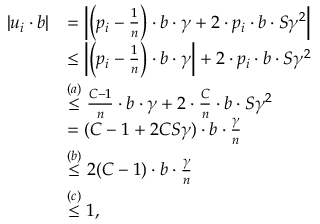Convert formula to latex. <formula><loc_0><loc_0><loc_500><loc_500>\begin{array} { r l } { | u _ { i } \cdot b | } & { = \left | \left ( p _ { i } - \frac { 1 } { n } \right ) \cdot b \cdot \gamma + 2 \cdot p _ { i } \cdot b \cdot S \gamma ^ { 2 } \right | } \\ & { \leq \left | \left ( p _ { i } - \frac { 1 } { n } \right ) \cdot b \cdot \gamma \right | + 2 \cdot p _ { i } \cdot b \cdot S \gamma ^ { 2 } } \\ & { \stackrel { ( a ) } { \leq } \frac { C - 1 } { n } \cdot b \cdot \gamma + 2 \cdot \frac { C } { n } \cdot b \cdot S \gamma ^ { 2 } } \\ & { = ( C - 1 + 2 C S \gamma ) \cdot b \cdot \frac { \gamma } { n } } \\ & { \stackrel { ( b ) } { \leq } 2 ( C - 1 ) \cdot b \cdot \frac { \gamma } { n } } \\ & { \stackrel { ( c ) } { \leq } 1 , } \end{array}</formula> 